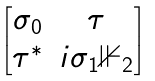Convert formula to latex. <formula><loc_0><loc_0><loc_500><loc_500>\begin{bmatrix} \sigma _ { 0 } & \tau \\ { \tau } ^ { * } & i \sigma _ { 1 } \mathbb { 1 } _ { 2 } \end{bmatrix}</formula> 